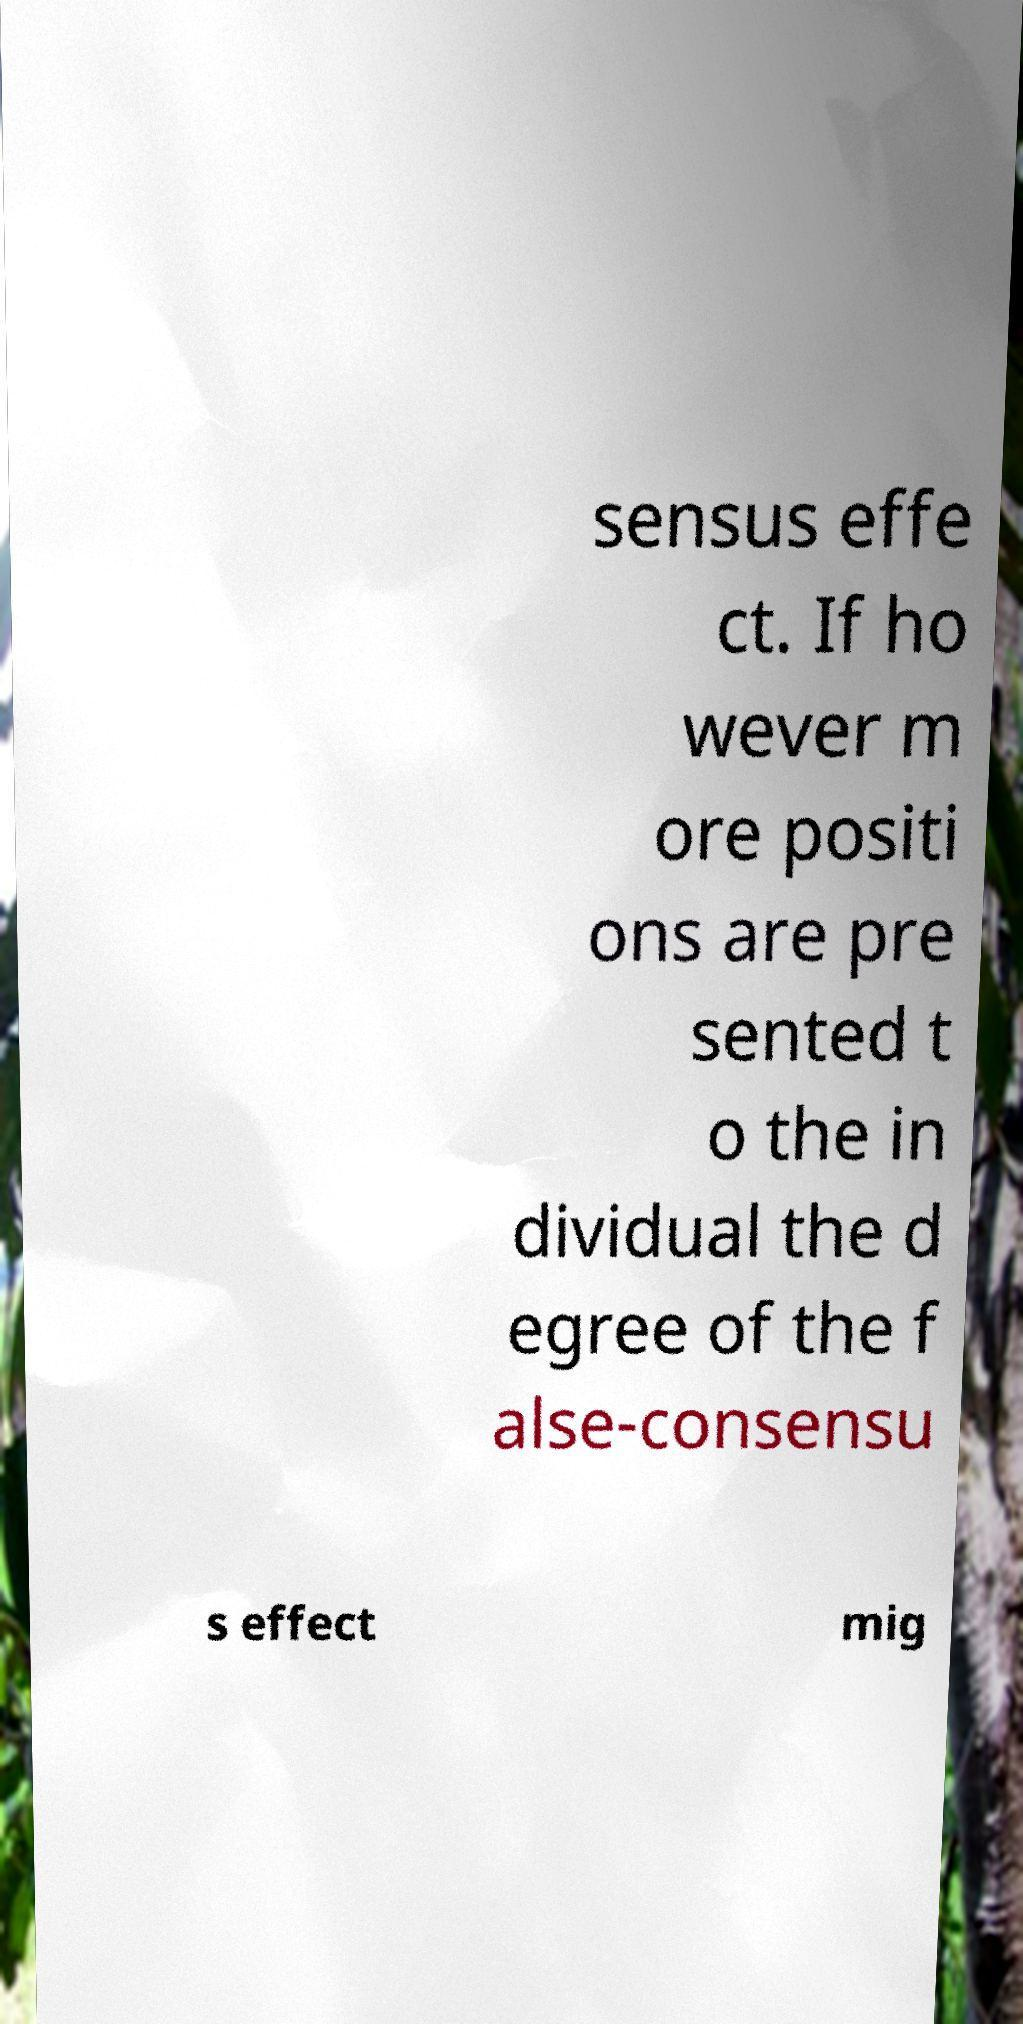Please identify and transcribe the text found in this image. sensus effe ct. If ho wever m ore positi ons are pre sented t o the in dividual the d egree of the f alse-consensu s effect mig 